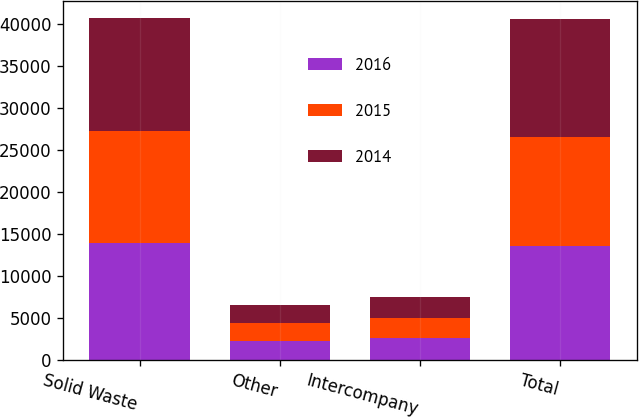Convert chart to OTSL. <chart><loc_0><loc_0><loc_500><loc_500><stacked_bar_chart><ecel><fcel>Solid Waste<fcel>Other<fcel>Intercompany<fcel>Total<nl><fcel>2016<fcel>13968<fcel>2278<fcel>2637<fcel>13609<nl><fcel>2015<fcel>13285<fcel>2065<fcel>2389<fcel>12961<nl><fcel>2014<fcel>13449<fcel>2191<fcel>2461<fcel>13996<nl></chart> 